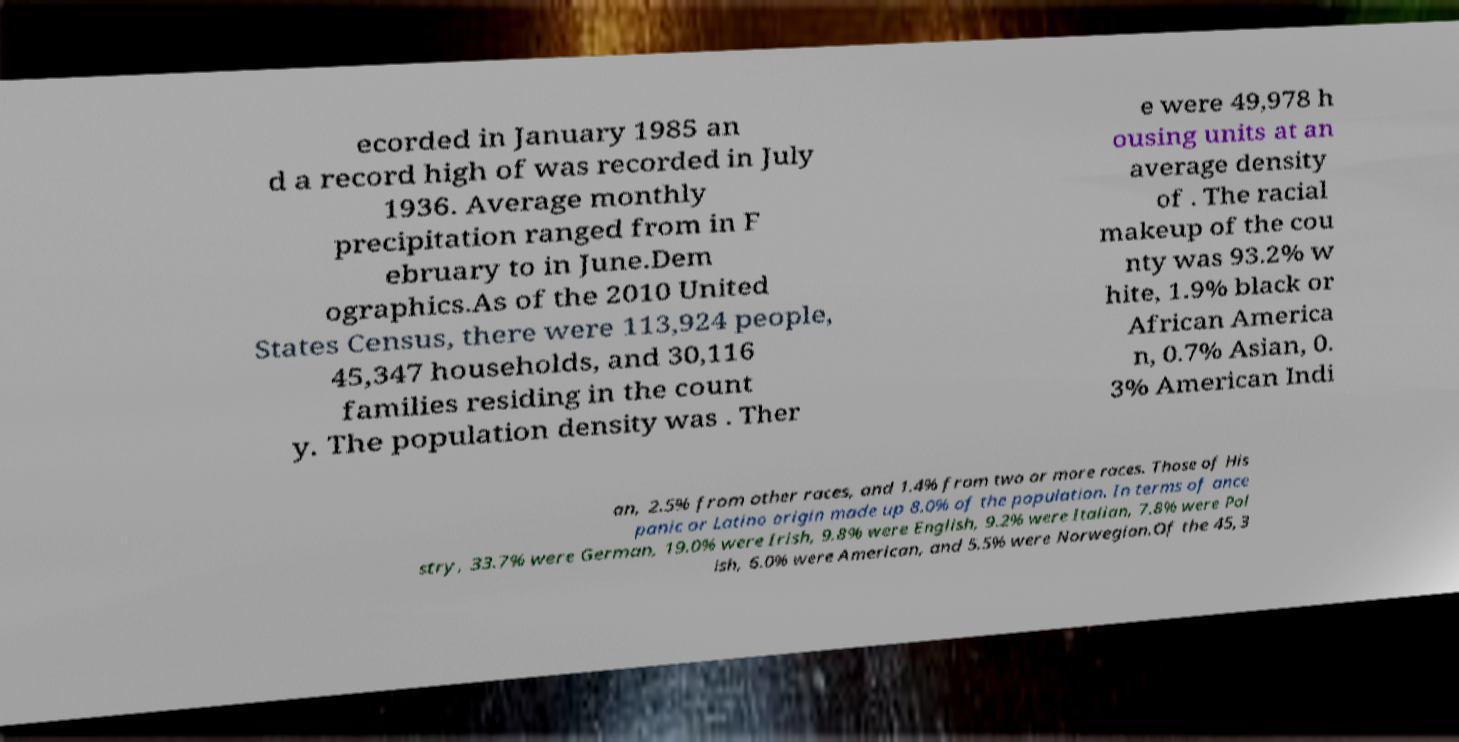Please read and relay the text visible in this image. What does it say? ecorded in January 1985 an d a record high of was recorded in July 1936. Average monthly precipitation ranged from in F ebruary to in June.Dem ographics.As of the 2010 United States Census, there were 113,924 people, 45,347 households, and 30,116 families residing in the count y. The population density was . Ther e were 49,978 h ousing units at an average density of . The racial makeup of the cou nty was 93.2% w hite, 1.9% black or African America n, 0.7% Asian, 0. 3% American Indi an, 2.5% from other races, and 1.4% from two or more races. Those of His panic or Latino origin made up 8.0% of the population. In terms of ance stry, 33.7% were German, 19.0% were Irish, 9.8% were English, 9.2% were Italian, 7.8% were Pol ish, 6.0% were American, and 5.5% were Norwegian.Of the 45,3 